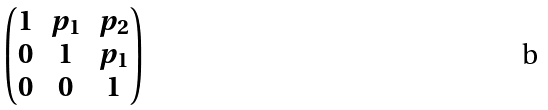<formula> <loc_0><loc_0><loc_500><loc_500>\begin{pmatrix} 1 & p _ { 1 } & p _ { 2 } \\ 0 & 1 & p _ { 1 } \\ 0 & 0 & 1 \end{pmatrix}</formula> 